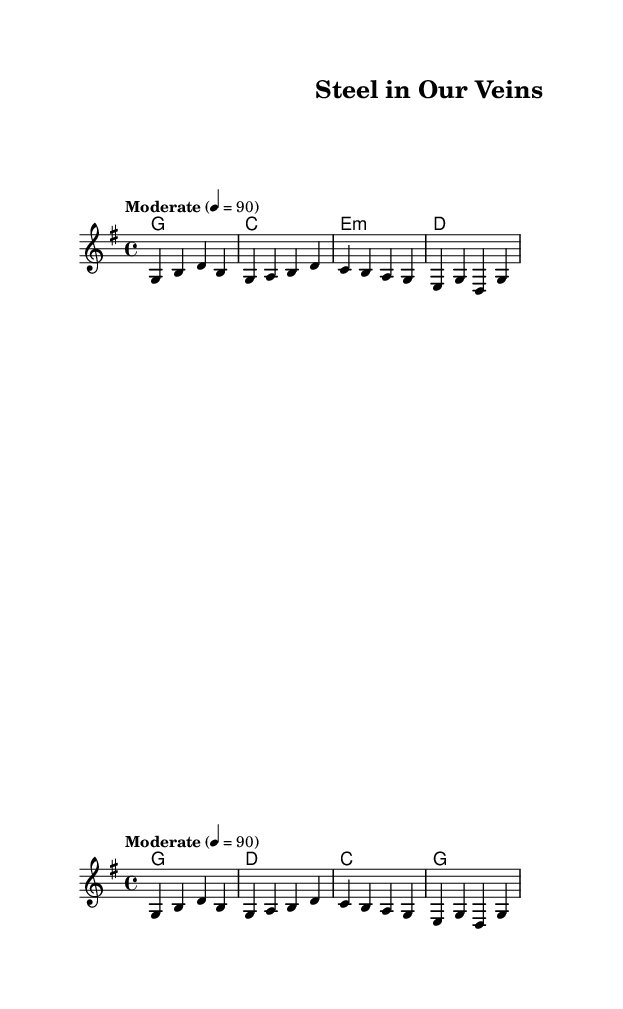What is the key signature of this music? The key signature is G major, which has one sharp (F#). This can be identified from the first few measures that indicate the key.
Answer: G major What is the time signature of this music? The time signature is 4/4, which can be found in the top section of the score where the time signature is indicated. This means there are four beats in a measure.
Answer: 4/4 What is the tempo marking for this piece? The tempo marking is "Moderate" with a tempo of quarter note equals 90. This is noted near the beginning of the score indicating the speed of the piece.
Answer: Moderate 4 = 90 How many measures are in the verse section? The verse section contains four measures, which can be counted from the melody section corresponding to the verse lyrics. Each group separated by bars represents a measure.
Answer: 4 What is the first lyric phrase of the verse? The first lyric phrase is "Great-grandpa's hands were calloused and strong," which is explicitly written in the verse lyrics section under the melody.
Answer: Great-grandpa's hands were calloused and strong What chords are used in the chorus? The chords used in the chorus are G, D, C, G. This can be found in the chord progression section indicated above the melody for the chorus.
Answer: G, D, C, G What thematic element does this song reflect? The song reflects the legacy of industrial workers and their descendants, as indicated by the lyrics discussing strength and hard work in building a future.
Answer: Legacy of industrial workers 